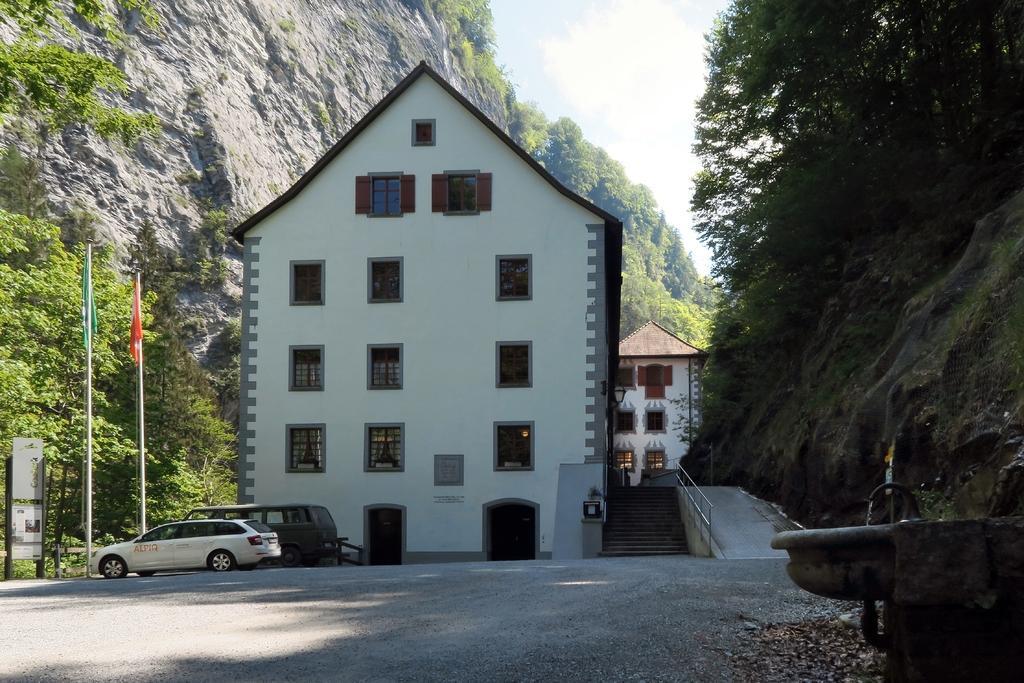In one or two sentences, can you explain what this image depicts? In this picture we can observe a building which is in white color. There are two vehicles parked on this road. We can observe two poles and two flags. There are trees. In the background there is a hill and a sky. 